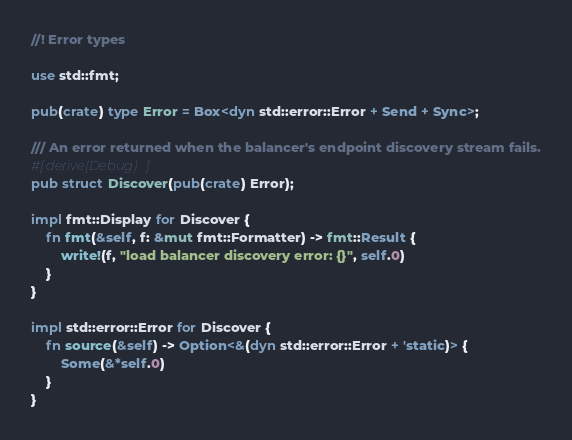<code> <loc_0><loc_0><loc_500><loc_500><_Rust_>//! Error types

use std::fmt;

pub(crate) type Error = Box<dyn std::error::Error + Send + Sync>;

/// An error returned when the balancer's endpoint discovery stream fails.
#[derive(Debug)]
pub struct Discover(pub(crate) Error);

impl fmt::Display for Discover {
    fn fmt(&self, f: &mut fmt::Formatter) -> fmt::Result {
        write!(f, "load balancer discovery error: {}", self.0)
    }
}

impl std::error::Error for Discover {
    fn source(&self) -> Option<&(dyn std::error::Error + 'static)> {
        Some(&*self.0)
    }
}
</code> 